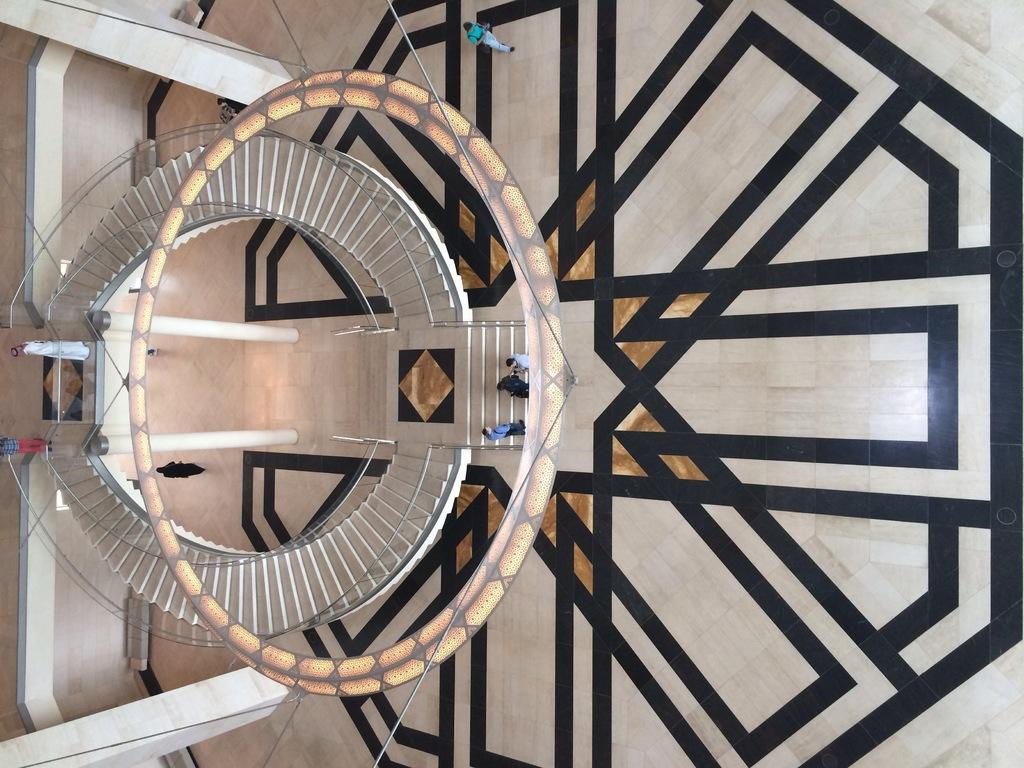What can be seen at the bottom of the image? The ground is visible in the image. What colors are present on the ground? The ground has cream, black, and brown colors. What architectural feature is present in the image? There are stairs in the image. Who or what is on the ground? There are people standing on the ground. What safety feature is present in the image? The railing is present in the image. How many vertical supports can be seen in the image? There are two pillars in the image. Can you see a boat twisting in the image? There is no boat present in the image, and therefore no twisting can be observed. 